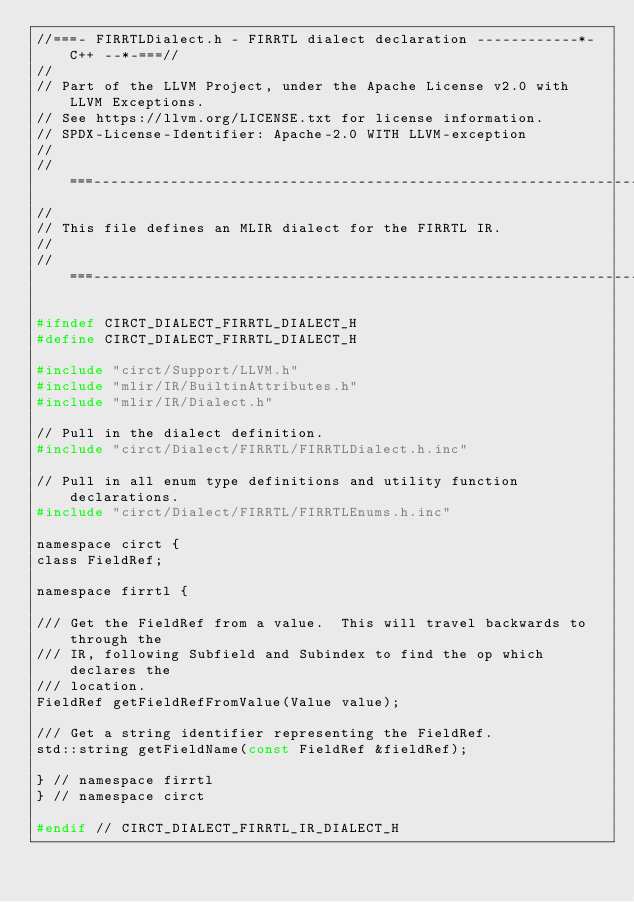Convert code to text. <code><loc_0><loc_0><loc_500><loc_500><_C_>//===- FIRRTLDialect.h - FIRRTL dialect declaration ------------*- C++ --*-===//
//
// Part of the LLVM Project, under the Apache License v2.0 with LLVM Exceptions.
// See https://llvm.org/LICENSE.txt for license information.
// SPDX-License-Identifier: Apache-2.0 WITH LLVM-exception
//
//===----------------------------------------------------------------------===//
//
// This file defines an MLIR dialect for the FIRRTL IR.
//
//===----------------------------------------------------------------------===//

#ifndef CIRCT_DIALECT_FIRRTL_DIALECT_H
#define CIRCT_DIALECT_FIRRTL_DIALECT_H

#include "circt/Support/LLVM.h"
#include "mlir/IR/BuiltinAttributes.h"
#include "mlir/IR/Dialect.h"

// Pull in the dialect definition.
#include "circt/Dialect/FIRRTL/FIRRTLDialect.h.inc"

// Pull in all enum type definitions and utility function declarations.
#include "circt/Dialect/FIRRTL/FIRRTLEnums.h.inc"

namespace circt {
class FieldRef;

namespace firrtl {

/// Get the FieldRef from a value.  This will travel backwards to through the
/// IR, following Subfield and Subindex to find the op which declares the
/// location.
FieldRef getFieldRefFromValue(Value value);

/// Get a string identifier representing the FieldRef.
std::string getFieldName(const FieldRef &fieldRef);

} // namespace firrtl
} // namespace circt

#endif // CIRCT_DIALECT_FIRRTL_IR_DIALECT_H
</code> 